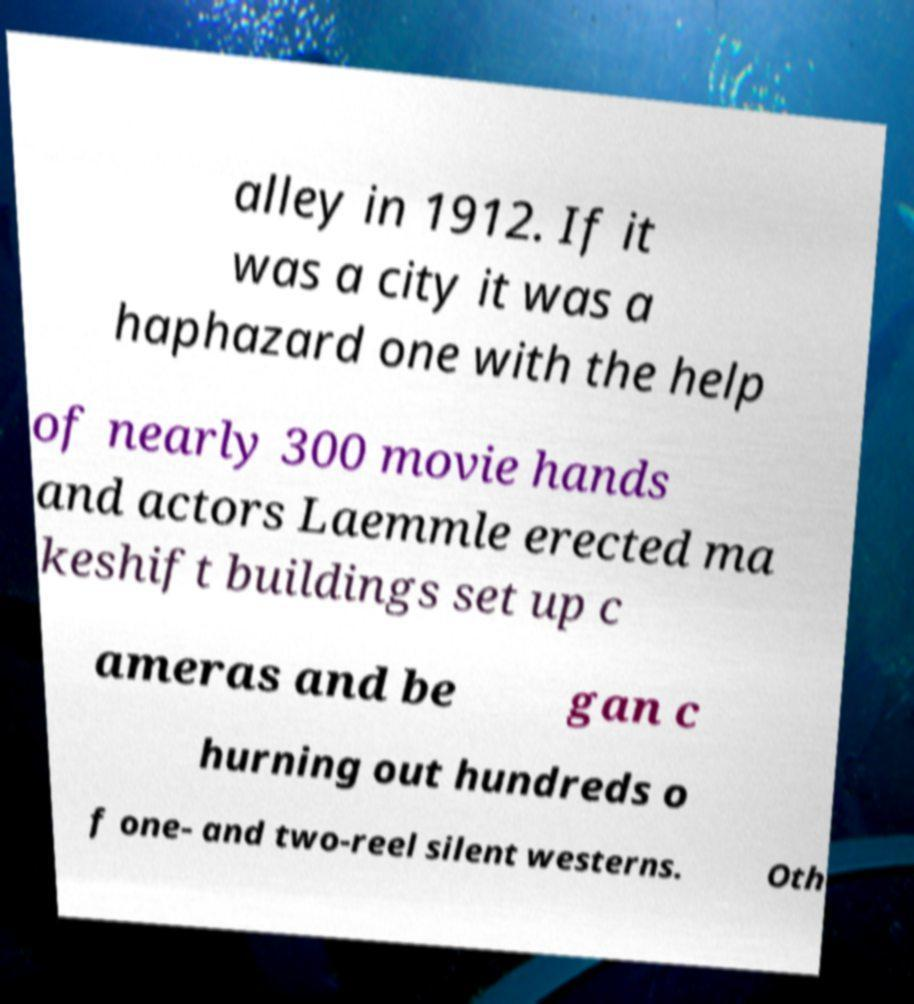What messages or text are displayed in this image? I need them in a readable, typed format. alley in 1912. If it was a city it was a haphazard one with the help of nearly 300 movie hands and actors Laemmle erected ma keshift buildings set up c ameras and be gan c hurning out hundreds o f one- and two-reel silent westerns. Oth 